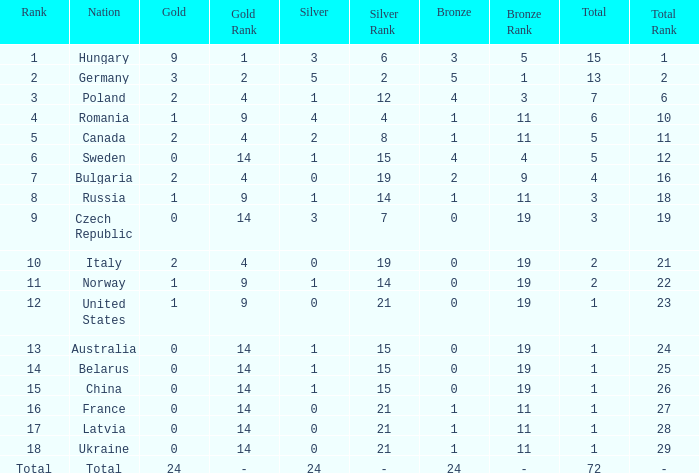What nation has 0 as the silver, 1 as the bronze, with 18 as the rank? Ukraine. 